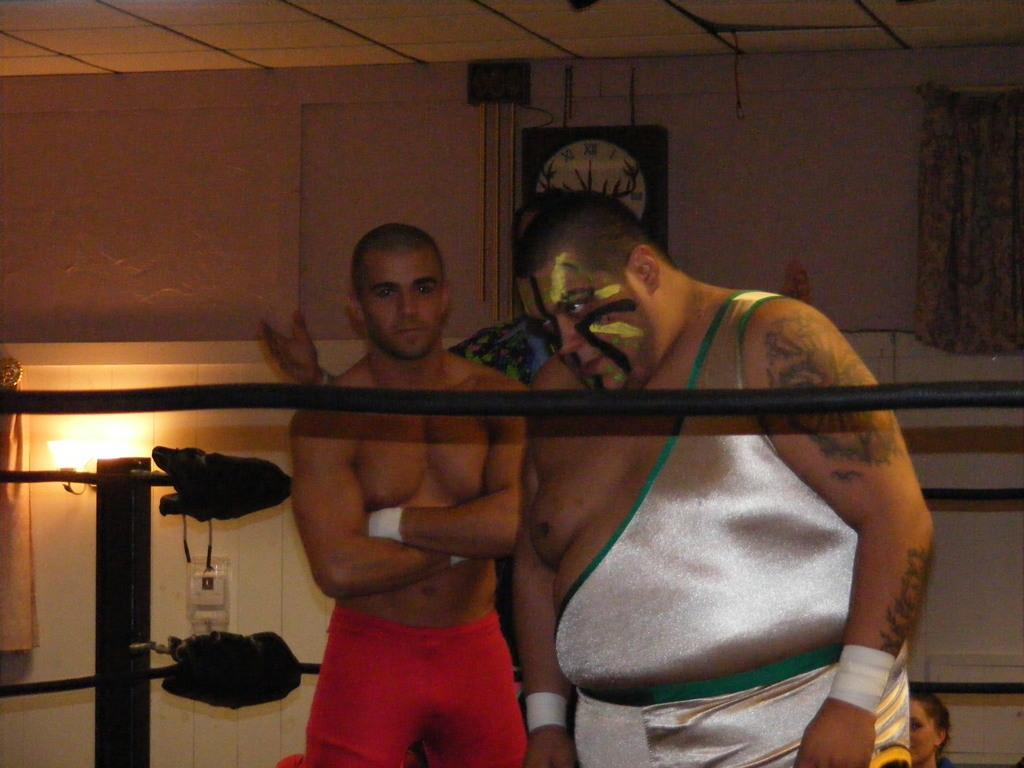How many people are in the image? There are three members in the image. What is the main setting of the image? There is a boxing ring in the image. Can you describe any background elements in the image? There is a wall clock visible in the background of the image. Are there any bookshelves visible in the image? There is no mention of bookshelves in the provided facts, and therefore, we cannot determine if they are present in the image. 